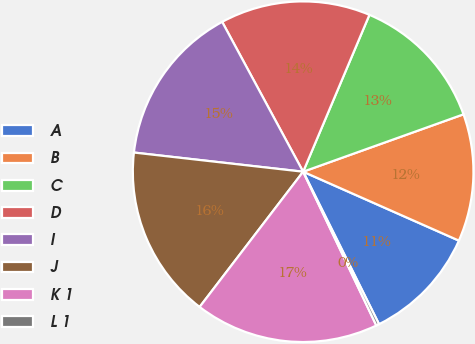Convert chart. <chart><loc_0><loc_0><loc_500><loc_500><pie_chart><fcel>A<fcel>B<fcel>C<fcel>D<fcel>I<fcel>J<fcel>K 1<fcel>L 1<nl><fcel>11.02%<fcel>12.1%<fcel>13.17%<fcel>14.25%<fcel>15.32%<fcel>16.4%<fcel>17.47%<fcel>0.28%<nl></chart> 